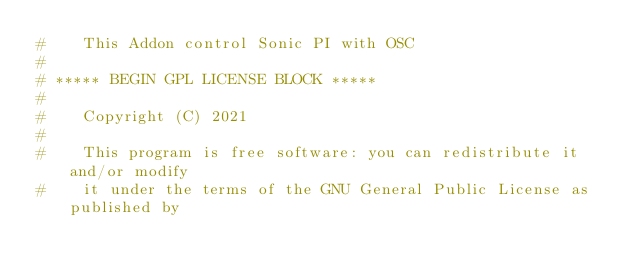Convert code to text. <code><loc_0><loc_0><loc_500><loc_500><_Python_>#    This Addon control Sonic PI with OSC 
#
# ***** BEGIN GPL LICENSE BLOCK *****
#
#    Copyright (C) 2021  
#
#    This program is free software: you can redistribute it and/or modify
#    it under the terms of the GNU General Public License as published by</code> 